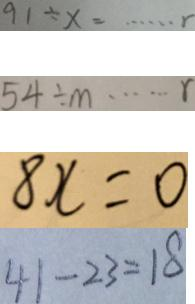Convert formula to latex. <formula><loc_0><loc_0><loc_500><loc_500>9 1 \div x = \cdots r 
 5 4 \div m \cdots r 
 8 x = 0 
 4 1 - 2 3 = 1 8</formula> 